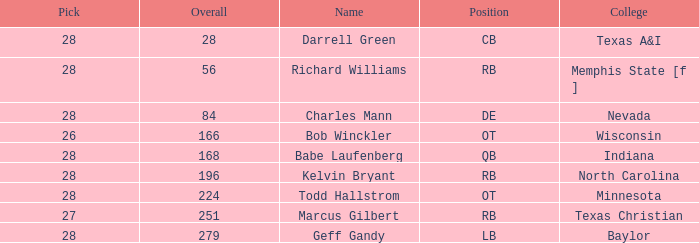For a player from baylor college with a pick below 28, what is their average round? None. 